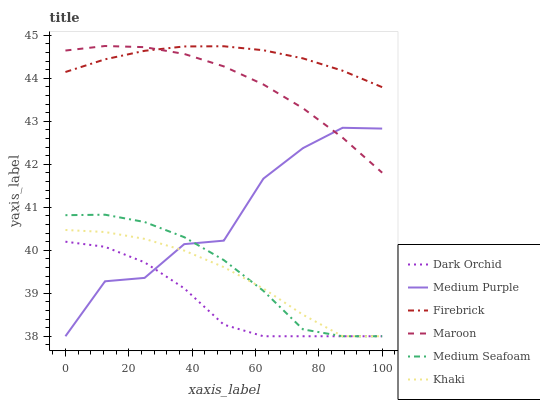Does Dark Orchid have the minimum area under the curve?
Answer yes or no. Yes. Does Firebrick have the maximum area under the curve?
Answer yes or no. Yes. Does Maroon have the minimum area under the curve?
Answer yes or no. No. Does Maroon have the maximum area under the curve?
Answer yes or no. No. Is Firebrick the smoothest?
Answer yes or no. Yes. Is Medium Purple the roughest?
Answer yes or no. Yes. Is Maroon the smoothest?
Answer yes or no. No. Is Maroon the roughest?
Answer yes or no. No. Does Khaki have the lowest value?
Answer yes or no. Yes. Does Maroon have the lowest value?
Answer yes or no. No. Does Maroon have the highest value?
Answer yes or no. Yes. Does Firebrick have the highest value?
Answer yes or no. No. Is Medium Purple less than Firebrick?
Answer yes or no. Yes. Is Firebrick greater than Khaki?
Answer yes or no. Yes. Does Medium Purple intersect Maroon?
Answer yes or no. Yes. Is Medium Purple less than Maroon?
Answer yes or no. No. Is Medium Purple greater than Maroon?
Answer yes or no. No. Does Medium Purple intersect Firebrick?
Answer yes or no. No. 